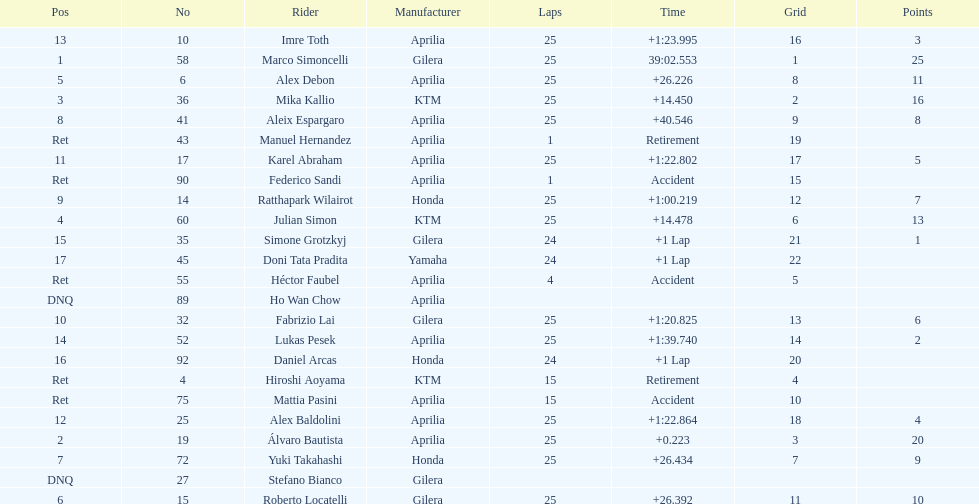The total amount of riders who did not qualify 2. 